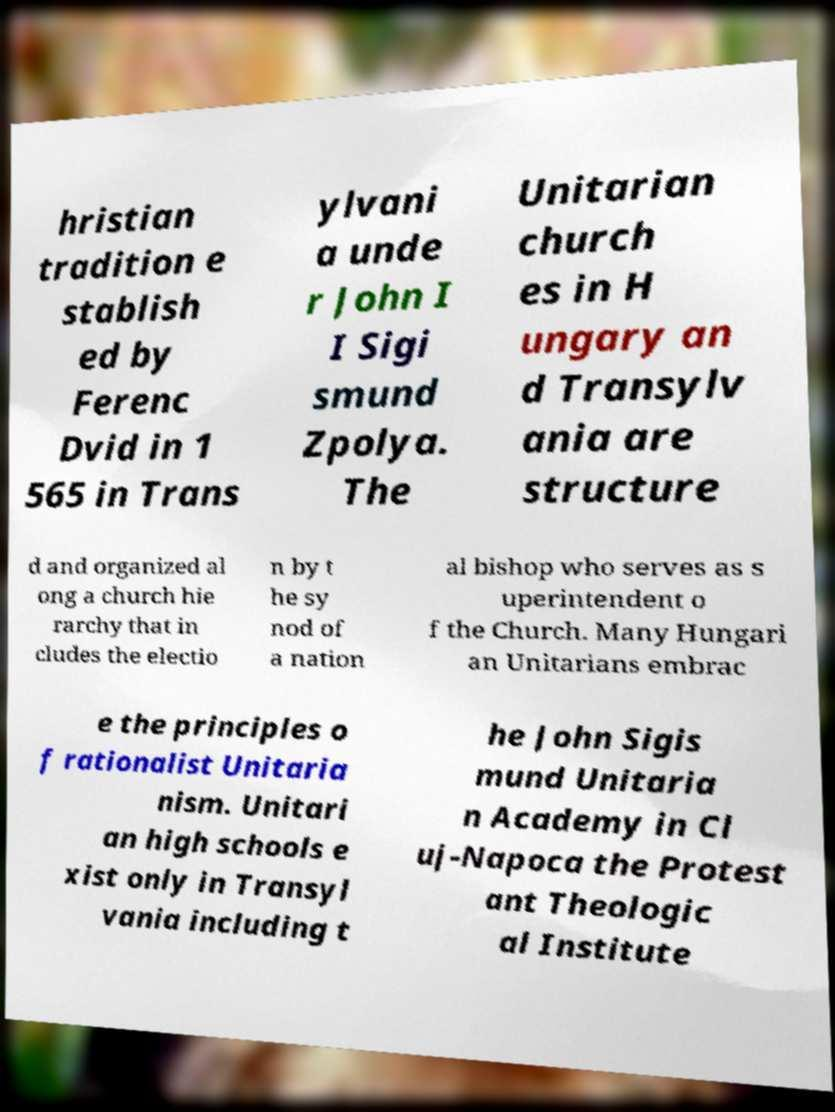Can you accurately transcribe the text from the provided image for me? hristian tradition e stablish ed by Ferenc Dvid in 1 565 in Trans ylvani a unde r John I I Sigi smund Zpolya. The Unitarian church es in H ungary an d Transylv ania are structure d and organized al ong a church hie rarchy that in cludes the electio n by t he sy nod of a nation al bishop who serves as s uperintendent o f the Church. Many Hungari an Unitarians embrac e the principles o f rationalist Unitaria nism. Unitari an high schools e xist only in Transyl vania including t he John Sigis mund Unitaria n Academy in Cl uj-Napoca the Protest ant Theologic al Institute 